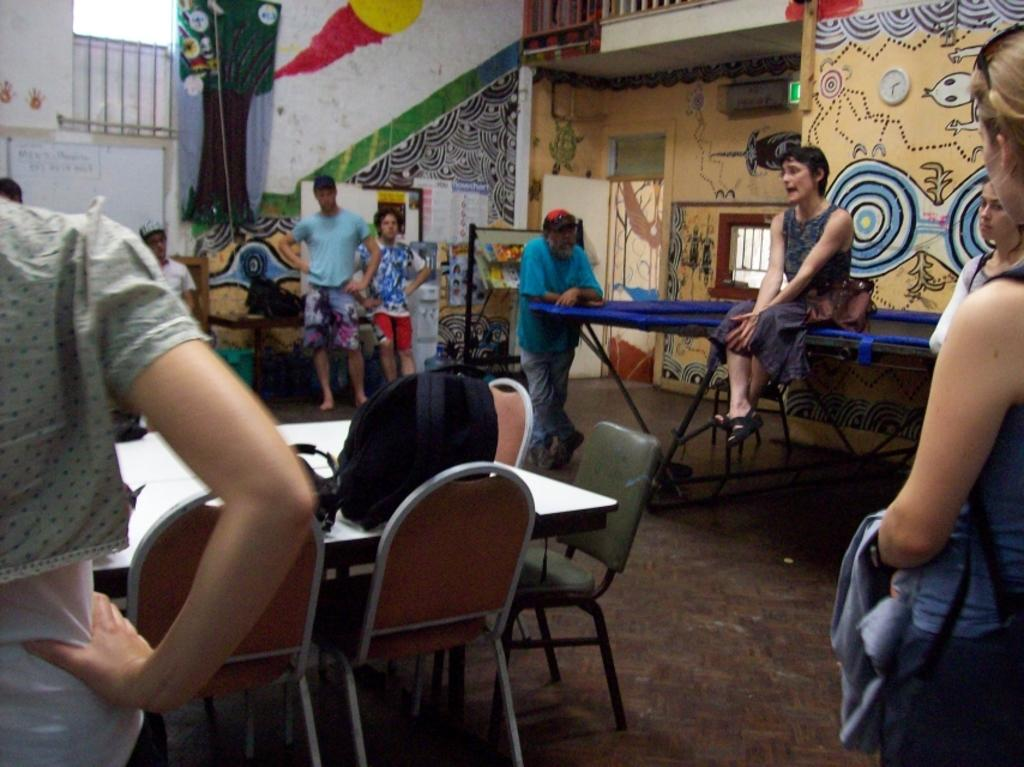What is happening with the group of people in the image? The people are sitting and standing in a room. Can you describe the objects in the room? There is a backpack on a table in the image. What can be seen on the walls in the image? There is graffiti on the walls in the image. What type of milk is being poured into the pencil in the image? There is no milk or pencil present in the image. 